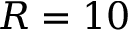<formula> <loc_0><loc_0><loc_500><loc_500>R = 1 0</formula> 